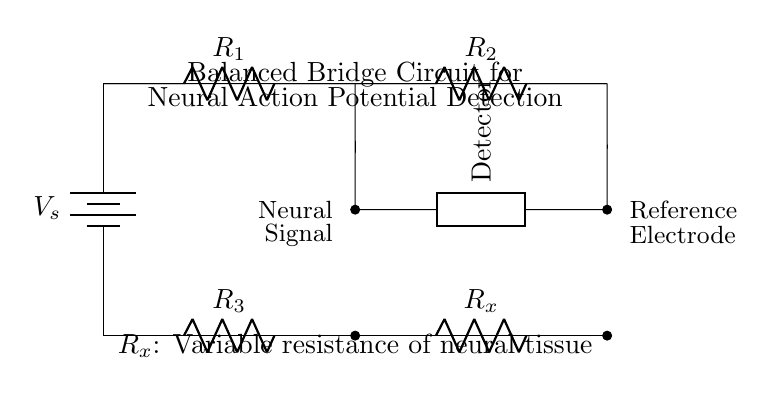What is the source voltage in this circuit? The source voltage is denoted as V_s, which represents the voltage supplied to the bridge circuit.
Answer: V_s What does R_x represent in the circuit? R_x is labeled as the variable resistance of neural tissue, indicating that it is adjustable to match the characteristics of the neural signal being detected.
Answer: Variable resistance of neural tissue Which component is labeled as the detector? The component labeled as Detector is located between the two horizontal lines and is connected to both R_2 and R_x, serving to detect the balance of the circuit in response to neural signals.
Answer: Detector How many resistors are used in the bridge circuit? The diagram shows four resistors labeled R_1, R_2, R_3, and R_x, making a total of four resistors in the balance bridge configuration.
Answer: Four What happens if R_x is equal to R_3? If R_x is equal to R_3, the bridge circuit becomes balanced, resulting in no voltage difference across the Detector, indicating that no neural action potential is detected.
Answer: No voltage difference Which electrodes are mentioned in the circuit? The circuit includes a neural signal electrode and a reference electrode, which are required for measuring the neural activity.
Answer: Neural signal and reference electrodes What is the function of the battery in this circuit? The battery serves as the power source (V_s) for the circuit, providing the necessary voltage to drive the current through the bridge and detect changes caused by neural activity.
Answer: Power source 